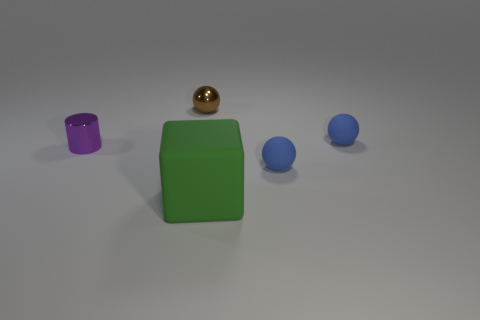Add 1 tiny purple things. How many objects exist? 6 Subtract all blocks. How many objects are left? 4 Add 5 brown balls. How many brown balls are left? 6 Add 1 brown things. How many brown things exist? 2 Subtract 0 blue blocks. How many objects are left? 5 Subtract all green metal balls. Subtract all small blue spheres. How many objects are left? 3 